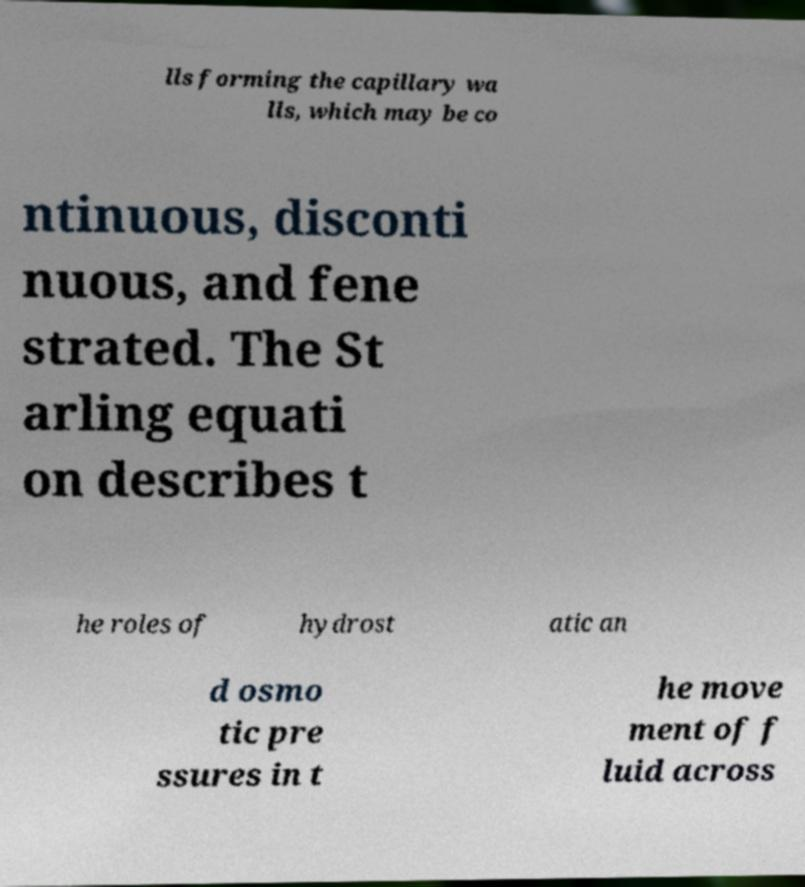What messages or text are displayed in this image? I need them in a readable, typed format. lls forming the capillary wa lls, which may be co ntinuous, disconti nuous, and fene strated. The St arling equati on describes t he roles of hydrost atic an d osmo tic pre ssures in t he move ment of f luid across 